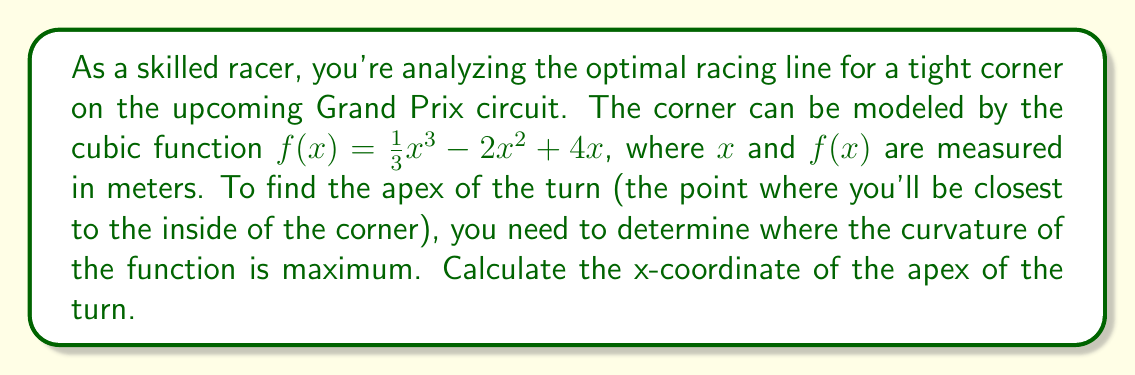What is the answer to this math problem? To find the point of maximum curvature for the cubic function, we need to follow these steps:

1) The curvature of a function is given by the formula:

   $$\kappa = \frac{|f''(x)|}{(1 + (f'(x))^2)^{3/2}}$$

2) First, let's find $f'(x)$ and $f''(x)$:
   
   $f'(x) = x^2 - 4x + 4$
   $f''(x) = 2x - 4$

3) The point of maximum curvature occurs where $f'''(x) = 0$. Let's calculate $f'''(x)$:
   
   $f'''(x) = 2$

4) Since $f'''(x)$ is a constant, the curvature doesn't have a maximum in the traditional sense. However, for a cubic function, the point of maximum curvature occurs at the inflection point, where $f''(x) = 0$.

5) Solve $f''(x) = 0$:
   
   $2x - 4 = 0$
   $2x = 4$
   $x = 2$

6) Therefore, the x-coordinate of the apex of the turn (point of maximum curvature) is at $x = 2$ meters.
Answer: $x = 2$ meters 